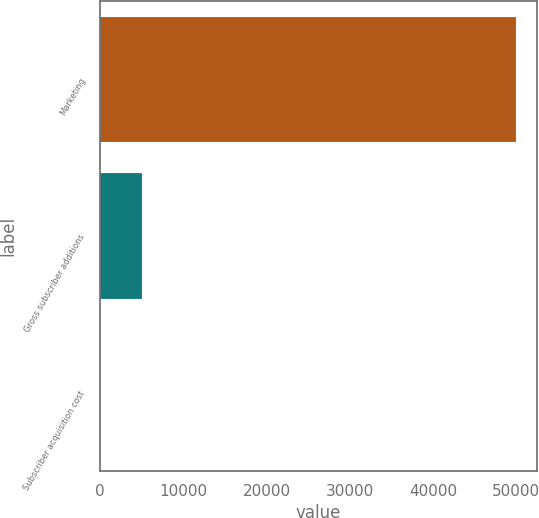<chart> <loc_0><loc_0><loc_500><loc_500><bar_chart><fcel>Marketing<fcel>Gross subscriber additions<fcel>Subscriber acquisition cost<nl><fcel>49949<fcel>5023.51<fcel>31.79<nl></chart> 